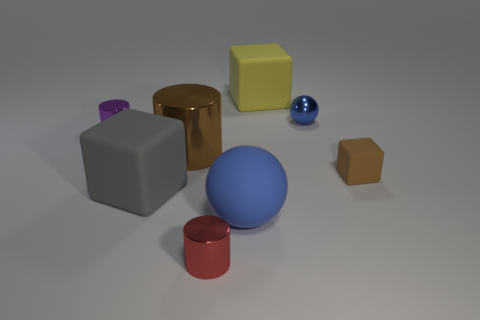Add 1 small purple metallic cylinders. How many objects exist? 9 Subtract all spheres. How many objects are left? 6 Subtract all large brown metal cylinders. Subtract all brown cylinders. How many objects are left? 6 Add 5 large matte cubes. How many large matte cubes are left? 7 Add 1 small blue cylinders. How many small blue cylinders exist? 1 Subtract 0 red cubes. How many objects are left? 8 